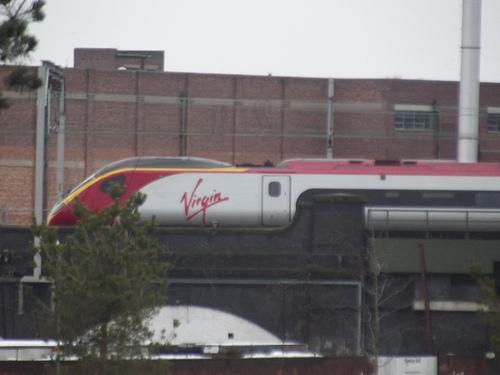How many trains are there?
Give a very brief answer. 1. How many tracks are there?
Give a very brief answer. 1. 